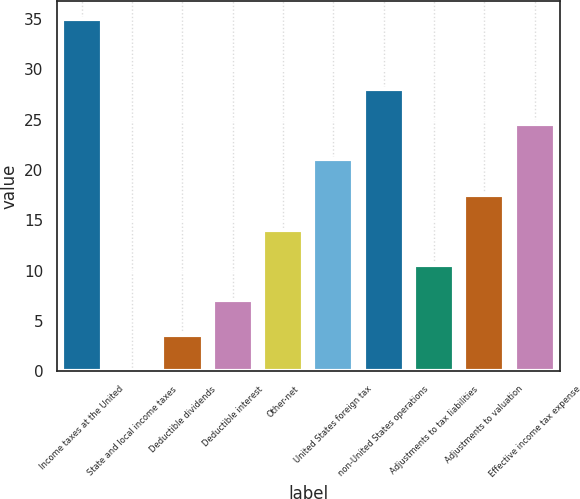Convert chart. <chart><loc_0><loc_0><loc_500><loc_500><bar_chart><fcel>Income taxes at the United<fcel>State and local income taxes<fcel>Deductible dividends<fcel>Deductible interest<fcel>Other-net<fcel>United States foreign tax<fcel>non-United States operations<fcel>Adjustments to tax liabilities<fcel>Adjustments to valuation<fcel>Effective income tax expense<nl><fcel>35<fcel>0.1<fcel>3.59<fcel>7.08<fcel>14.06<fcel>21.04<fcel>28.02<fcel>10.57<fcel>17.55<fcel>24.53<nl></chart> 